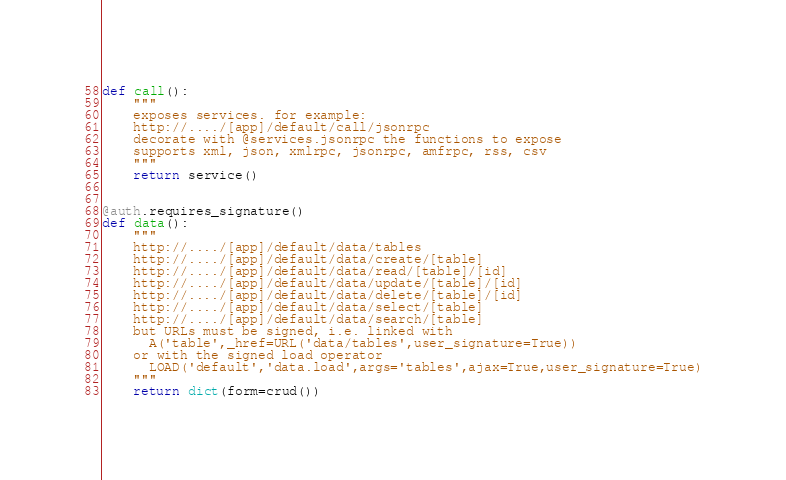<code> <loc_0><loc_0><loc_500><loc_500><_Python_>

def call():
    """
    exposes services. for example:
    http://..../[app]/default/call/jsonrpc
    decorate with @services.jsonrpc the functions to expose
    supports xml, json, xmlrpc, jsonrpc, amfrpc, rss, csv
    """
    return service()


@auth.requires_signature()
def data():
    """
    http://..../[app]/default/data/tables
    http://..../[app]/default/data/create/[table]
    http://..../[app]/default/data/read/[table]/[id]
    http://..../[app]/default/data/update/[table]/[id]
    http://..../[app]/default/data/delete/[table]/[id]
    http://..../[app]/default/data/select/[table]
    http://..../[app]/default/data/search/[table]
    but URLs must be signed, i.e. linked with
      A('table',_href=URL('data/tables',user_signature=True))
    or with the signed load operator
      LOAD('default','data.load',args='tables',ajax=True,user_signature=True)
    """
    return dict(form=crud())
</code> 